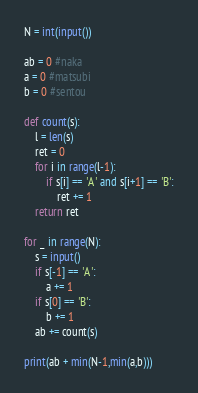Convert code to text. <code><loc_0><loc_0><loc_500><loc_500><_Python_>N = int(input())

ab = 0 #naka
a = 0 #matsubi
b = 0 #sentou

def count(s):
    l = len(s)
    ret = 0
    for i in range(l-1):
        if s[i] == 'A' and s[i+1] == 'B':
            ret += 1
    return ret

for _ in range(N):
    s = input()
    if s[-1] == 'A':
        a += 1
    if s[0] == 'B':
        b += 1
    ab += count(s)
    
print(ab + min(N-1,min(a,b)))</code> 